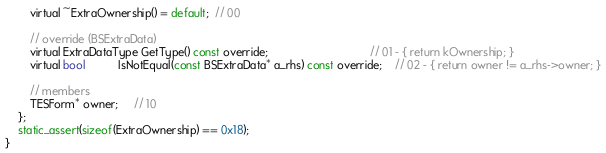Convert code to text. <code><loc_0><loc_0><loc_500><loc_500><_C_>		virtual ~ExtraOwnership() = default;  // 00

		// override (BSExtraData)
		virtual ExtraDataType GetType() const override;								// 01 - { return kOwnership; }
		virtual bool		  IsNotEqual(const BSExtraData* a_rhs) const override;	// 02 - { return owner != a_rhs->owner; }

		// members
		TESForm* owner;	 // 10
	};
	static_assert(sizeof(ExtraOwnership) == 0x18);
}
</code> 